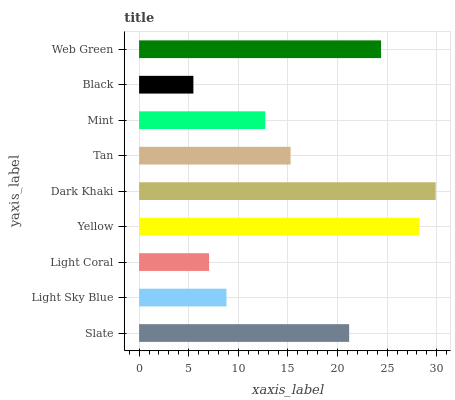Is Black the minimum?
Answer yes or no. Yes. Is Dark Khaki the maximum?
Answer yes or no. Yes. Is Light Sky Blue the minimum?
Answer yes or no. No. Is Light Sky Blue the maximum?
Answer yes or no. No. Is Slate greater than Light Sky Blue?
Answer yes or no. Yes. Is Light Sky Blue less than Slate?
Answer yes or no. Yes. Is Light Sky Blue greater than Slate?
Answer yes or no. No. Is Slate less than Light Sky Blue?
Answer yes or no. No. Is Tan the high median?
Answer yes or no. Yes. Is Tan the low median?
Answer yes or no. Yes. Is Web Green the high median?
Answer yes or no. No. Is Light Sky Blue the low median?
Answer yes or no. No. 